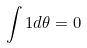Convert formula to latex. <formula><loc_0><loc_0><loc_500><loc_500>\int 1 d \theta = 0</formula> 